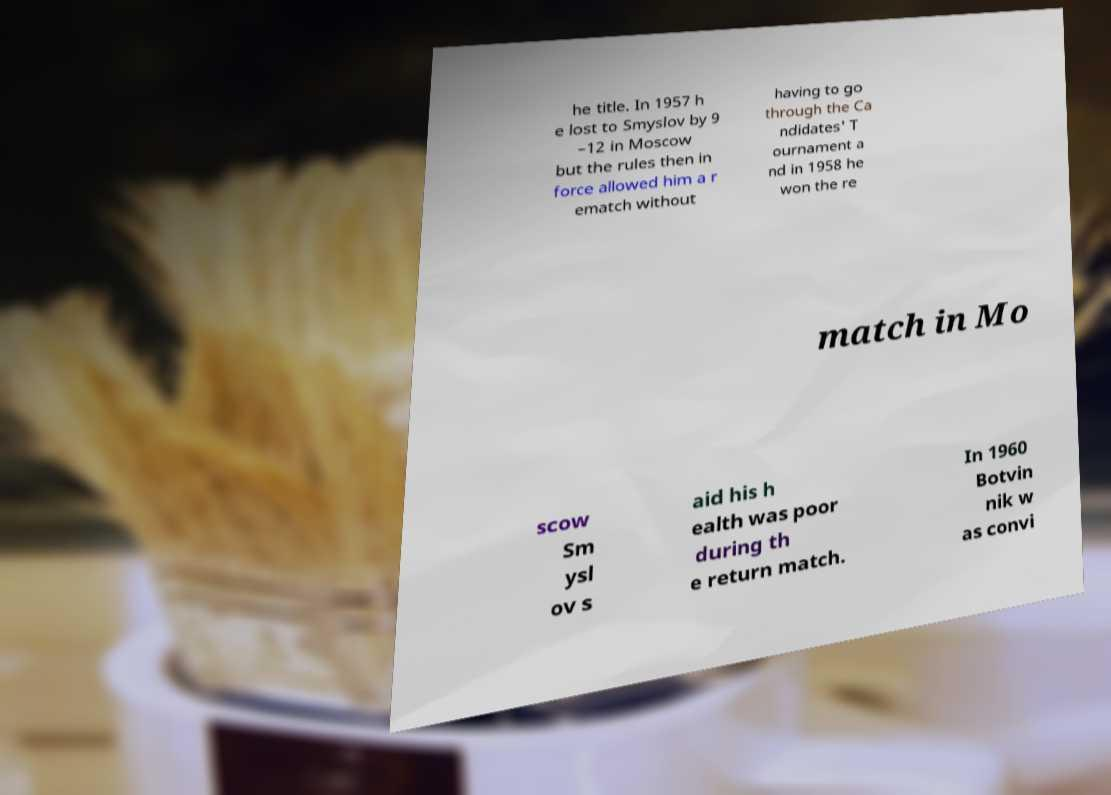I need the written content from this picture converted into text. Can you do that? he title. In 1957 h e lost to Smyslov by 9 –12 in Moscow but the rules then in force allowed him a r ematch without having to go through the Ca ndidates' T ournament a nd in 1958 he won the re match in Mo scow Sm ysl ov s aid his h ealth was poor during th e return match. In 1960 Botvin nik w as convi 